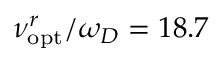Convert formula to latex. <formula><loc_0><loc_0><loc_500><loc_500>\nu _ { o p t } ^ { r } / \omega _ { D } = 1 8 . 7</formula> 